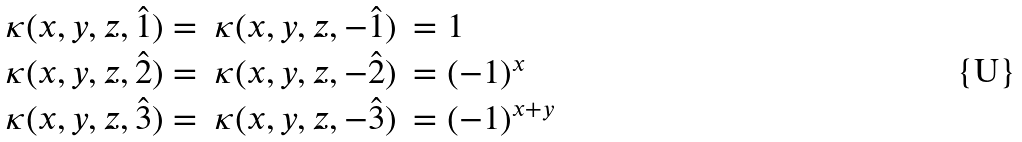Convert formula to latex. <formula><loc_0><loc_0><loc_500><loc_500>\begin{array} { r c l } \kappa ( x , y , z , \hat { 1 } ) = & \kappa ( x , y , z , - \hat { 1 } ) & = 1 \\ \kappa ( x , y , z , \hat { 2 } ) = & \kappa ( x , y , z , - \hat { 2 } ) & = ( - 1 ) ^ { x } \\ \kappa ( x , y , z , \hat { 3 } ) = & \kappa ( x , y , z , - \hat { 3 } ) & = ( - 1 ) ^ { x + y } \end{array}</formula> 